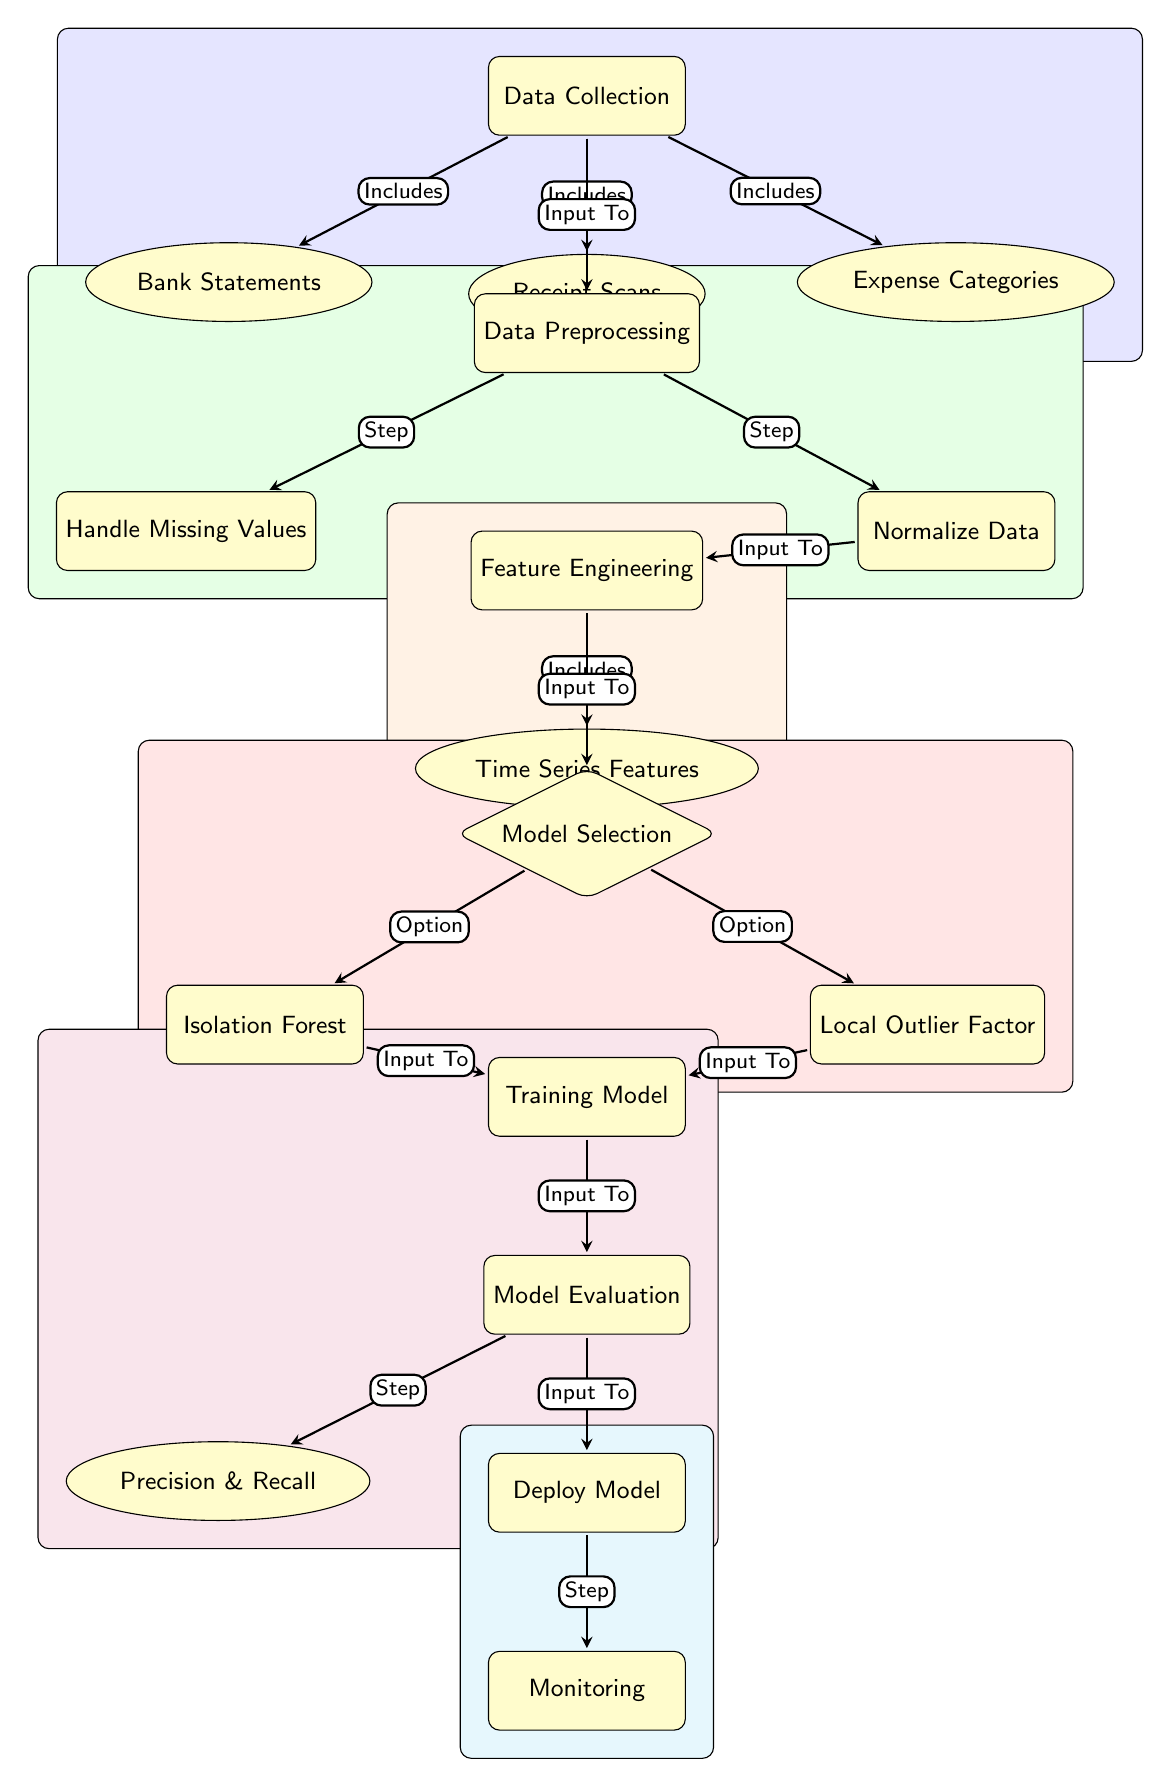What are the three sources of data in the data collection node? The diagram clearly lists three data sources connected to the "Data Collection" node: Bank Statements, Receipt Scans, and Expense Categories.
Answer: Bank Statements, Receipt Scans, Expense Categories What are the two methods of model selection depicted in the diagram? The diagram illustrates two options under the "Model Selection" decision node: Isolation Forest and Local Outlier Factor.
Answer: Isolation Forest, Local Outlier Factor How many main processes are involved in the diagram? The diagram features five main processes: Data Collection, Data Preprocessing, Feature Engineering, Model Selection, and Deploy Model. Counting these main processes gives a total of five.
Answer: Five Which process comes directly after feature engineering? According to the diagram flow, the process that follows "Feature Engineering" is "Model Selection." This is indicated by the arrows pointing down from "Feature Engineering."
Answer: Model Selection What is the purpose of the Handling Missing Values process? The "Handle Missing Values" process is a critical part of "Data Preprocessing," where missing data entries are addressed before further processing. It’s specifically concerned with ensuring data integrity.
Answer: Addressing missing data What is the immediate output of the training model process? The diagram indicates that the immediate output of the "Training Model" process is sent to the "Model Evaluation" process, as shown by the direct arrow connecting the two processes.
Answer: Model Evaluation What color corresponds to the Feature Engineering section in the diagram? The "Feature Engineering" section is represented in orange, which is visually distinct in the diagram due to its background color highlighting the related nodes.
Answer: Orange What are the outputs measured in the model evaluation process? The "Model Evaluation" process has an output connected to the node labeled "Precision & Recall," indicating that these metrics are specifically evaluated after the model training stage.
Answer: Precision & Recall Which process is responsible for ongoing monitoring? The "Monitoring" process follows the "Deploy Model" stage, indicating that it is the final step dedicated to tracking the model's performance in operational use.
Answer: Monitoring 